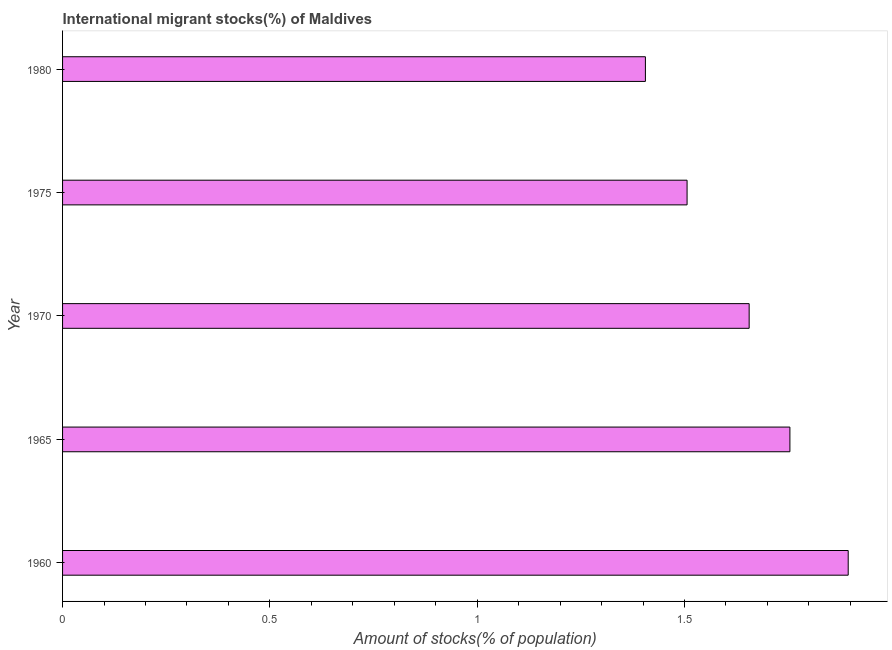What is the title of the graph?
Your answer should be very brief. International migrant stocks(%) of Maldives. What is the label or title of the X-axis?
Your response must be concise. Amount of stocks(% of population). What is the label or title of the Y-axis?
Offer a terse response. Year. What is the number of international migrant stocks in 1965?
Your answer should be compact. 1.75. Across all years, what is the maximum number of international migrant stocks?
Your answer should be compact. 1.89. Across all years, what is the minimum number of international migrant stocks?
Ensure brevity in your answer.  1.41. In which year was the number of international migrant stocks maximum?
Your answer should be very brief. 1960. In which year was the number of international migrant stocks minimum?
Offer a terse response. 1980. What is the sum of the number of international migrant stocks?
Make the answer very short. 8.22. What is the average number of international migrant stocks per year?
Keep it short and to the point. 1.64. What is the median number of international migrant stocks?
Ensure brevity in your answer.  1.66. In how many years, is the number of international migrant stocks greater than 1 %?
Keep it short and to the point. 5. Do a majority of the years between 1960 and 1980 (inclusive) have number of international migrant stocks greater than 1.5 %?
Keep it short and to the point. Yes. What is the ratio of the number of international migrant stocks in 1965 to that in 1970?
Give a very brief answer. 1.06. Is the difference between the number of international migrant stocks in 1960 and 1980 greater than the difference between any two years?
Make the answer very short. Yes. What is the difference between the highest and the second highest number of international migrant stocks?
Your response must be concise. 0.14. Is the sum of the number of international migrant stocks in 1970 and 1980 greater than the maximum number of international migrant stocks across all years?
Keep it short and to the point. Yes. What is the difference between the highest and the lowest number of international migrant stocks?
Keep it short and to the point. 0.49. In how many years, is the number of international migrant stocks greater than the average number of international migrant stocks taken over all years?
Your answer should be compact. 3. How many bars are there?
Your answer should be very brief. 5. Are all the bars in the graph horizontal?
Provide a short and direct response. Yes. How many years are there in the graph?
Ensure brevity in your answer.  5. What is the Amount of stocks(% of population) in 1960?
Provide a short and direct response. 1.89. What is the Amount of stocks(% of population) in 1965?
Ensure brevity in your answer.  1.75. What is the Amount of stocks(% of population) in 1970?
Provide a succinct answer. 1.66. What is the Amount of stocks(% of population) of 1975?
Your answer should be compact. 1.51. What is the Amount of stocks(% of population) in 1980?
Your response must be concise. 1.41. What is the difference between the Amount of stocks(% of population) in 1960 and 1965?
Offer a terse response. 0.14. What is the difference between the Amount of stocks(% of population) in 1960 and 1970?
Your answer should be very brief. 0.24. What is the difference between the Amount of stocks(% of population) in 1960 and 1975?
Offer a very short reply. 0.39. What is the difference between the Amount of stocks(% of population) in 1960 and 1980?
Your response must be concise. 0.49. What is the difference between the Amount of stocks(% of population) in 1965 and 1970?
Give a very brief answer. 0.1. What is the difference between the Amount of stocks(% of population) in 1965 and 1975?
Give a very brief answer. 0.25. What is the difference between the Amount of stocks(% of population) in 1965 and 1980?
Your answer should be compact. 0.35. What is the difference between the Amount of stocks(% of population) in 1970 and 1975?
Give a very brief answer. 0.15. What is the difference between the Amount of stocks(% of population) in 1970 and 1980?
Your response must be concise. 0.25. What is the difference between the Amount of stocks(% of population) in 1975 and 1980?
Provide a succinct answer. 0.1. What is the ratio of the Amount of stocks(% of population) in 1960 to that in 1965?
Keep it short and to the point. 1.08. What is the ratio of the Amount of stocks(% of population) in 1960 to that in 1970?
Offer a terse response. 1.14. What is the ratio of the Amount of stocks(% of population) in 1960 to that in 1975?
Ensure brevity in your answer.  1.26. What is the ratio of the Amount of stocks(% of population) in 1960 to that in 1980?
Provide a short and direct response. 1.35. What is the ratio of the Amount of stocks(% of population) in 1965 to that in 1970?
Your answer should be very brief. 1.06. What is the ratio of the Amount of stocks(% of population) in 1965 to that in 1975?
Provide a short and direct response. 1.17. What is the ratio of the Amount of stocks(% of population) in 1965 to that in 1980?
Offer a very short reply. 1.25. What is the ratio of the Amount of stocks(% of population) in 1970 to that in 1975?
Ensure brevity in your answer.  1.1. What is the ratio of the Amount of stocks(% of population) in 1970 to that in 1980?
Ensure brevity in your answer.  1.18. What is the ratio of the Amount of stocks(% of population) in 1975 to that in 1980?
Offer a terse response. 1.07. 